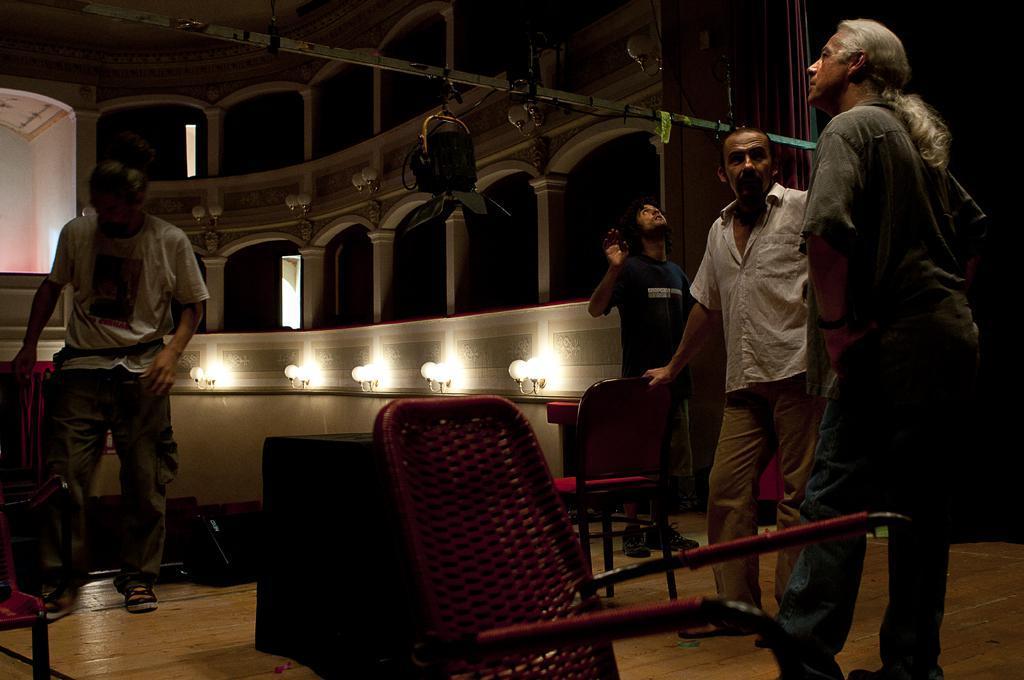Could you give a brief overview of what you see in this image? In this image I can see four persons standing. There are chairs, lights, pillars and there is a camera crane. Also there are some objects. 